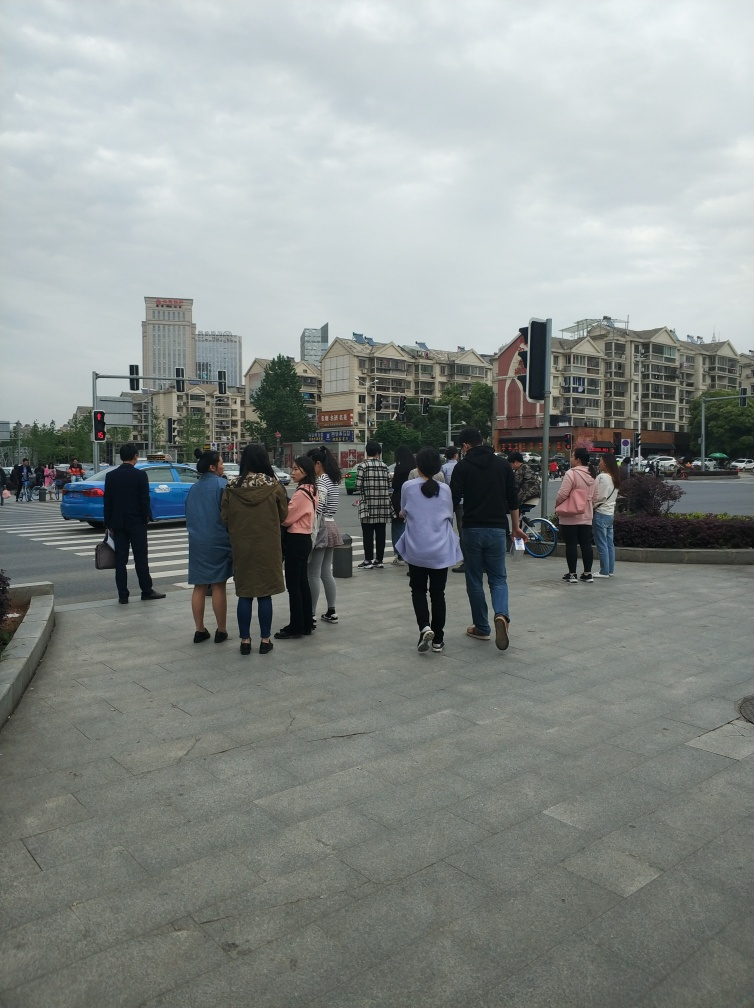What are the dominant colors in this photograph? The dominant colors in the photo are muted tones of gray and blue, particularly due to the overcast sky and the urban setting, interspersed with the colors from people's clothing and some building facades. 